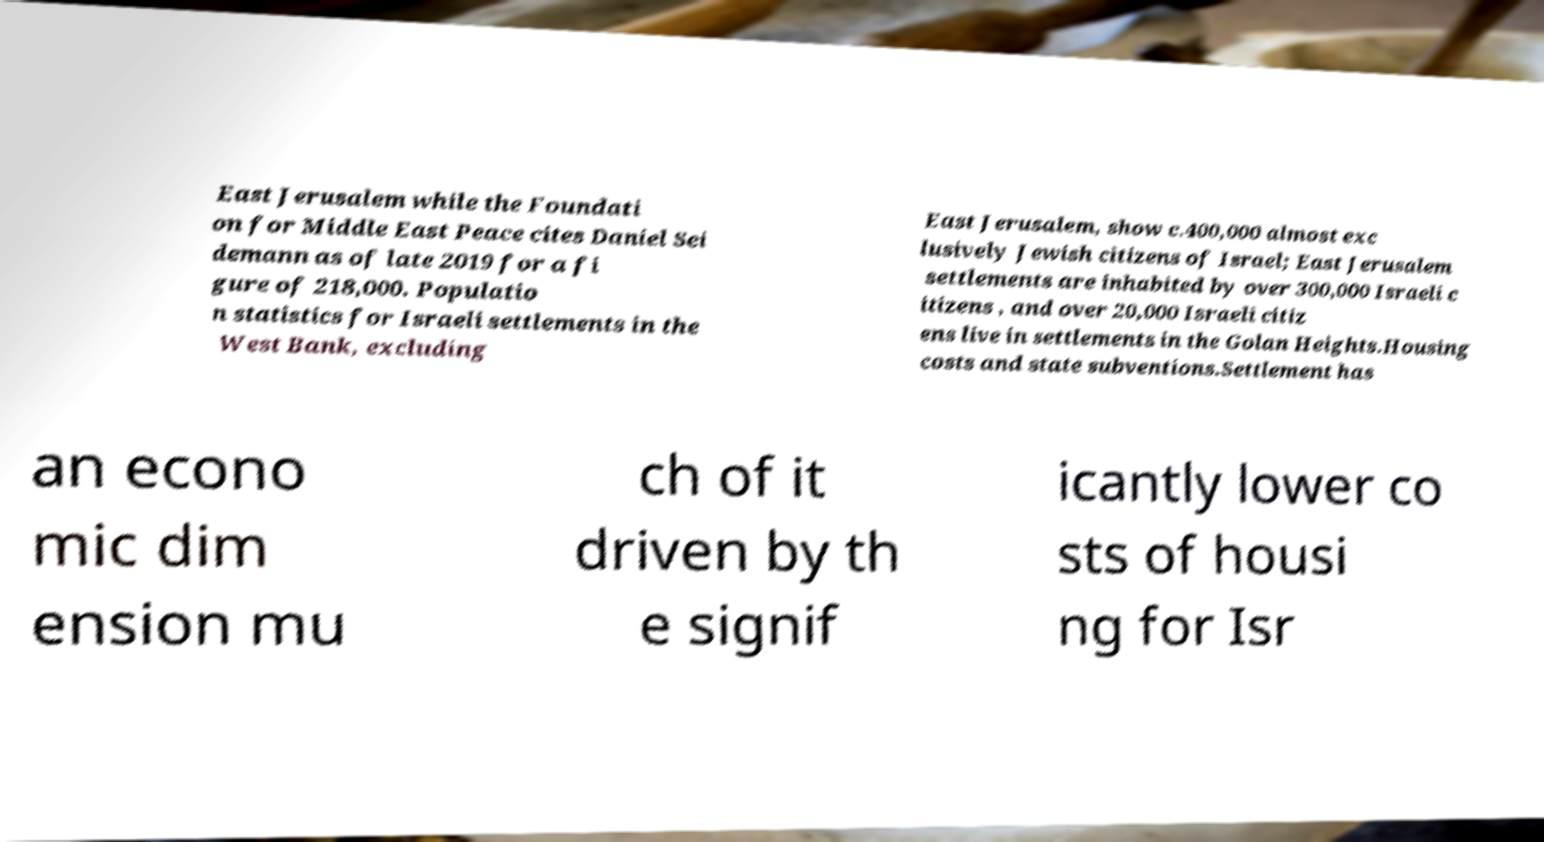Please identify and transcribe the text found in this image. East Jerusalem while the Foundati on for Middle East Peace cites Daniel Sei demann as of late 2019 for a fi gure of 218,000. Populatio n statistics for Israeli settlements in the West Bank, excluding East Jerusalem, show c.400,000 almost exc lusively Jewish citizens of Israel; East Jerusalem settlements are inhabited by over 300,000 Israeli c itizens , and over 20,000 Israeli citiz ens live in settlements in the Golan Heights.Housing costs and state subventions.Settlement has an econo mic dim ension mu ch of it driven by th e signif icantly lower co sts of housi ng for Isr 